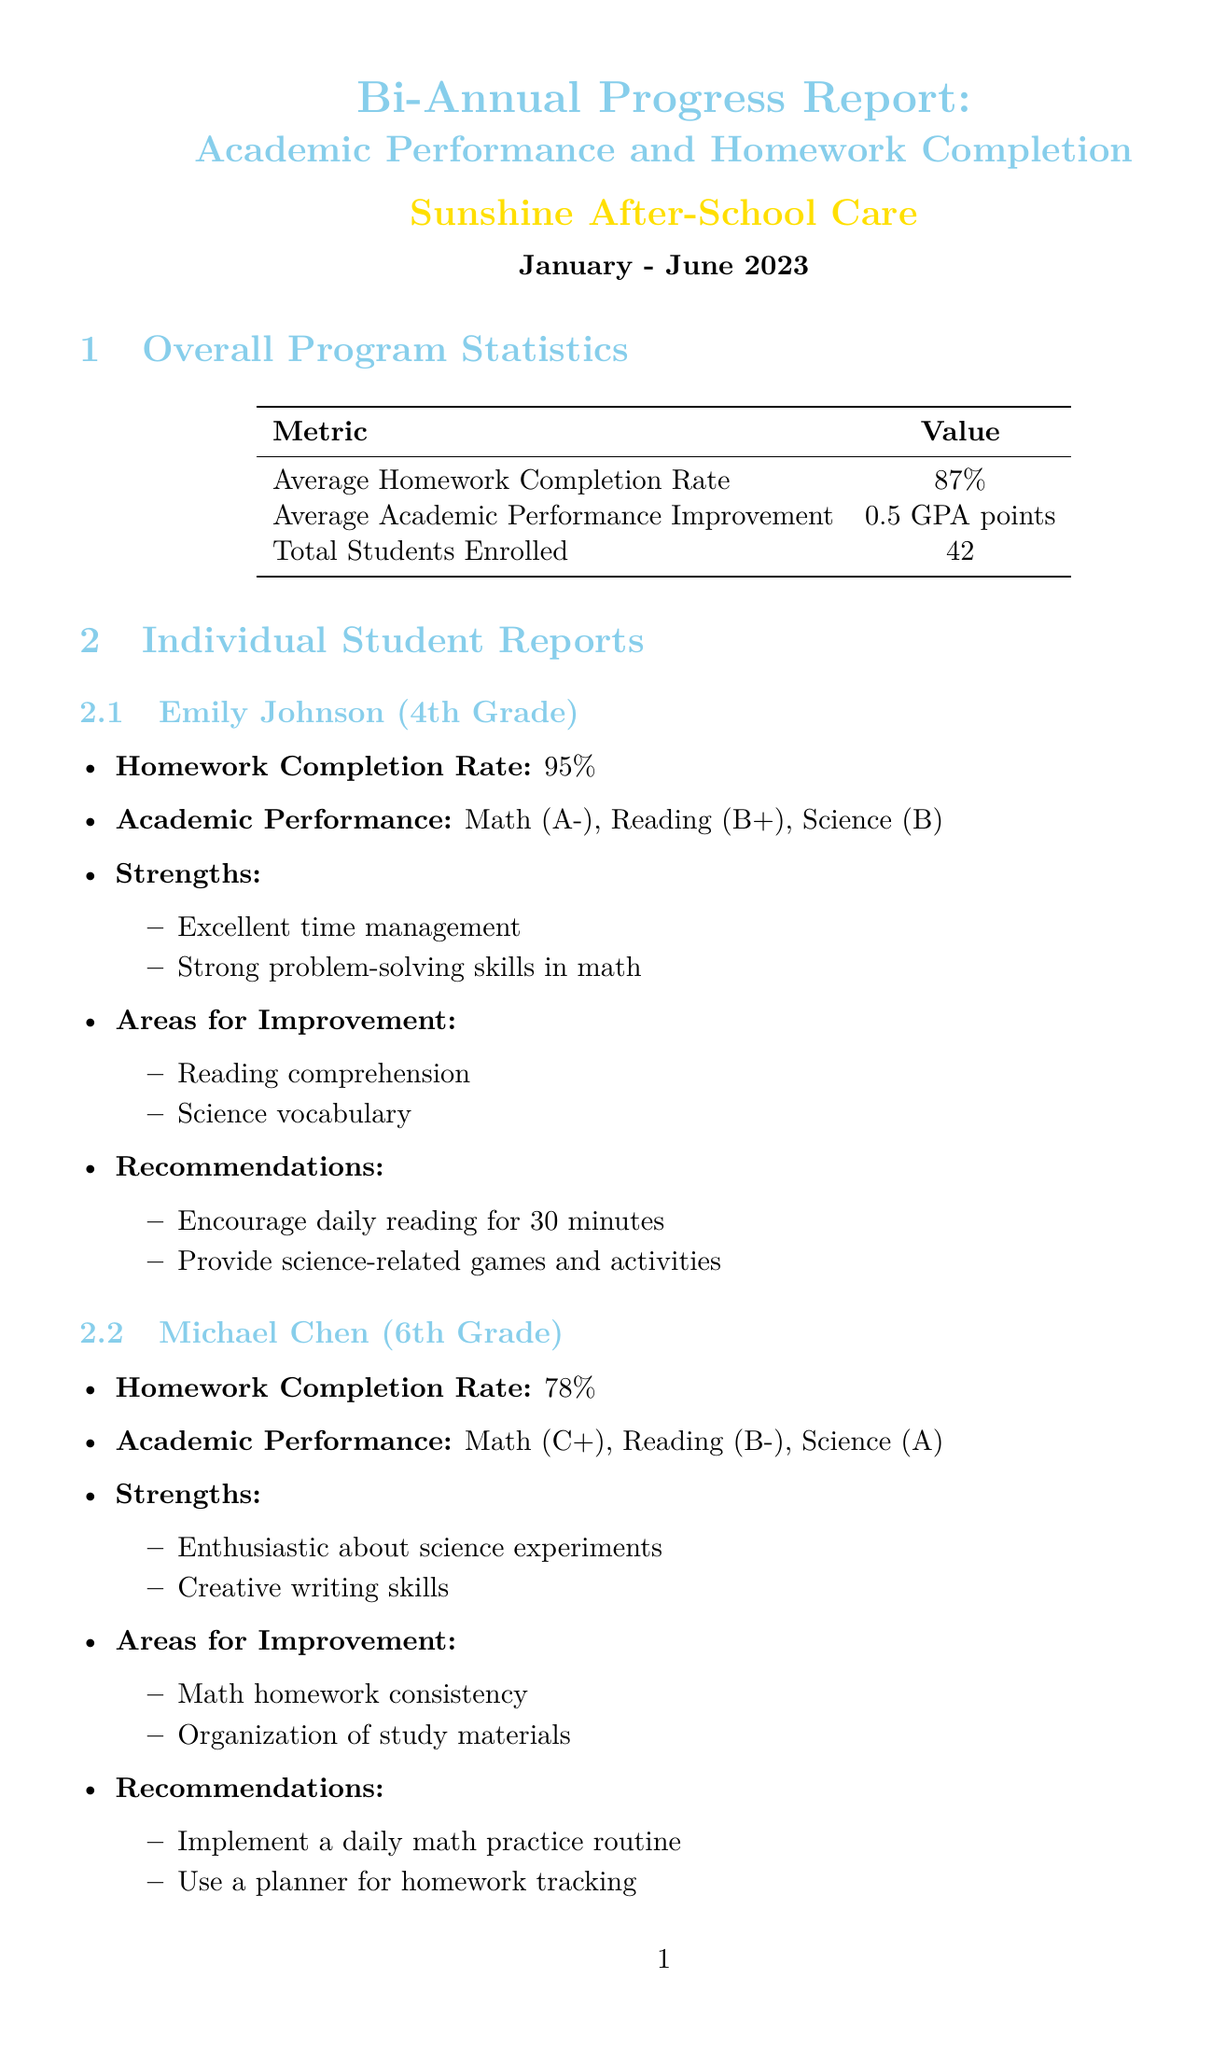What is the average homework completion rate? The average homework completion rate is mentioned as a specific percentage in the Overall Program Statistics section of the document.
Answer: 87% What is Emily Johnson's grade? Emily Johnson's grade is noted in the Individual Student Reports section.
Answer: 4th What are Michael Chen's strengths? Michael Chen's strengths are detailed in the Individual Student Reports section and listed as specific skills.
Answer: Enthusiastic about science experiments, Creative writing skills What is the purpose of IXL Learning? The purpose of IXL Learning is explicitly defined in the Resource Allocation section.
Answer: Personalized math and language arts practice What is the total number of students enrolled? The total number of students enrolled is provided in the Overall Program Statistics section as a specific number.
Answer: 42 What is one recommendation for Emily Johnson? One recommendation for Emily Johnson is specified among various suggestions to support her academic growth.
Answer: Encourage daily reading for 30 minutes What method is suggested for improving homework completion? A method suggested for improving homework completion is listed in the Support Strategies section under Homework Completion.
Answer: Establish a structured homework time What type of activities are included in the future goals? The future goals include specific types of activities that are mentioned toward the end of the document.
Answer: STEM-focused activities What is the conclusion of the report? The conclusion of the report summarizes the overall effectiveness of the program as stated in the Conclusion section.
Answer: The Sunshine After-School Care program has shown positive results in supporting students' academic growth and homework completion 